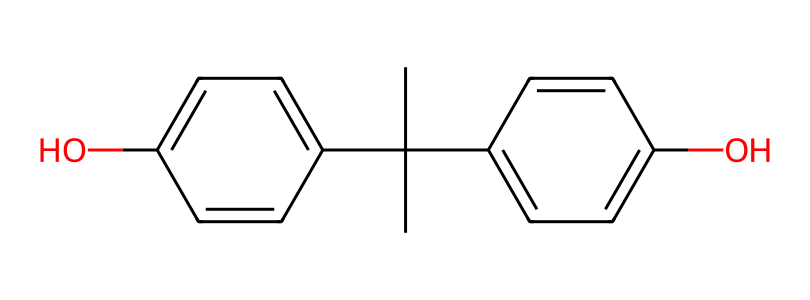how many rings are present in bisphenol A? The structure of bisphenol A contains two distinct phenolic rings connected by a central carbon backbone. Each ring is a structural component of the molecule, leading to a total of two rings.
Answer: 2 what type of functional groups are present in this chemical? In the structure, there are hydroxyl (–OH) groups attached to the phenolic rings. These groups indicate that bisphenol A is a diol, specifically a diphenolic compound, due to the presence of two –OH groups.
Answer: hydroxyl groups is bisphenol A considered toxic? Bisphenol A is classified as an endocrine disruptor and has been associated with various health risks, such as hormone-related disorders, making it toxic in certain concentrations.
Answer: yes how many carbon atoms are in bisphenol A? By analyzing the molecular structure, one can count the number of carbon atoms present. The count reveals that there are 15 carbon atoms in bisphenol A, making it a fairly large organic compound.
Answer: 15 what is the molecular formula of bisphenol A? The molecular formula is derived from counting each type of atom in the structure. For bisphenol A, the counts reveal 15 carbons, 16 hydrogens, and 2 oxygens, indicating the molecular formula C15H16O2.
Answer: C15H16O2 what characteristic property does bisphenol A give to plastics? Bisphenol A is known for providing rigidity and durability to plastics, specifically polycarbonate and epoxy resins, enhancing their strength and thermal resistance.
Answer: rigidity and durability 